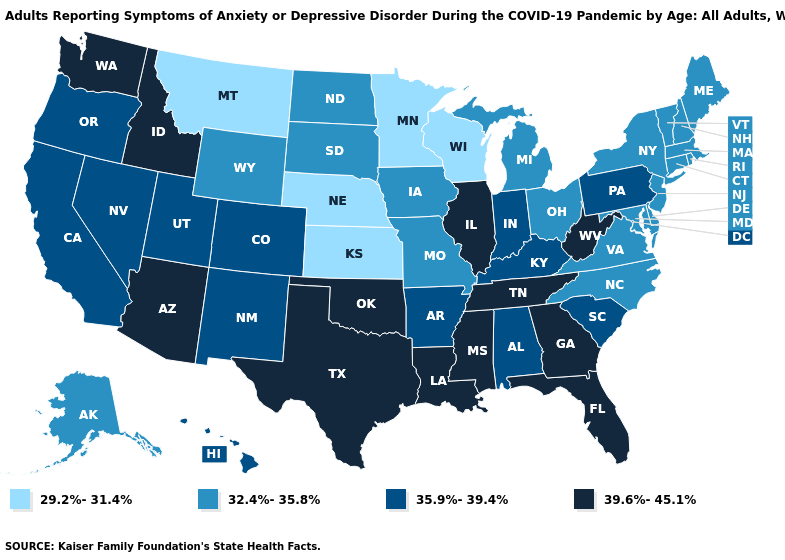What is the value of Massachusetts?
Be succinct. 32.4%-35.8%. Name the states that have a value in the range 32.4%-35.8%?
Give a very brief answer. Alaska, Connecticut, Delaware, Iowa, Maine, Maryland, Massachusetts, Michigan, Missouri, New Hampshire, New Jersey, New York, North Carolina, North Dakota, Ohio, Rhode Island, South Dakota, Vermont, Virginia, Wyoming. Name the states that have a value in the range 35.9%-39.4%?
Quick response, please. Alabama, Arkansas, California, Colorado, Hawaii, Indiana, Kentucky, Nevada, New Mexico, Oregon, Pennsylvania, South Carolina, Utah. Name the states that have a value in the range 35.9%-39.4%?
Quick response, please. Alabama, Arkansas, California, Colorado, Hawaii, Indiana, Kentucky, Nevada, New Mexico, Oregon, Pennsylvania, South Carolina, Utah. Does Georgia have the highest value in the South?
Answer briefly. Yes. What is the lowest value in the South?
Write a very short answer. 32.4%-35.8%. What is the value of Louisiana?
Concise answer only. 39.6%-45.1%. Name the states that have a value in the range 32.4%-35.8%?
Concise answer only. Alaska, Connecticut, Delaware, Iowa, Maine, Maryland, Massachusetts, Michigan, Missouri, New Hampshire, New Jersey, New York, North Carolina, North Dakota, Ohio, Rhode Island, South Dakota, Vermont, Virginia, Wyoming. What is the value of North Dakota?
Write a very short answer. 32.4%-35.8%. Name the states that have a value in the range 32.4%-35.8%?
Write a very short answer. Alaska, Connecticut, Delaware, Iowa, Maine, Maryland, Massachusetts, Michigan, Missouri, New Hampshire, New Jersey, New York, North Carolina, North Dakota, Ohio, Rhode Island, South Dakota, Vermont, Virginia, Wyoming. What is the value of Maine?
Keep it brief. 32.4%-35.8%. Which states have the highest value in the USA?
Concise answer only. Arizona, Florida, Georgia, Idaho, Illinois, Louisiana, Mississippi, Oklahoma, Tennessee, Texas, Washington, West Virginia. Is the legend a continuous bar?
Short answer required. No. What is the lowest value in the South?
Give a very brief answer. 32.4%-35.8%. Does Virginia have the same value as Pennsylvania?
Quick response, please. No. 